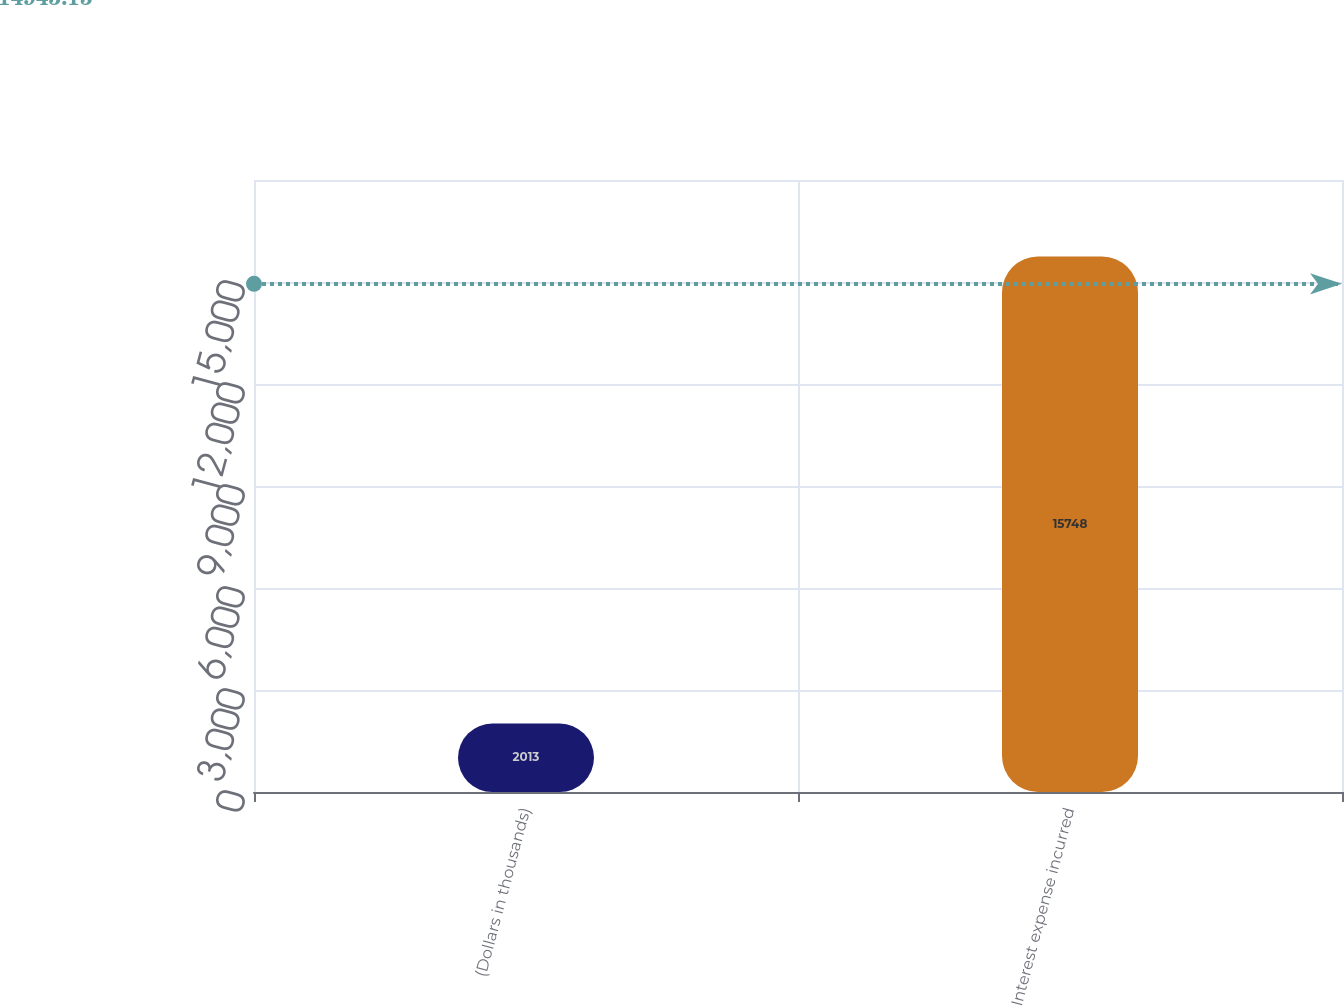<chart> <loc_0><loc_0><loc_500><loc_500><bar_chart><fcel>(Dollars in thousands)<fcel>Interest expense incurred<nl><fcel>2013<fcel>15748<nl></chart> 